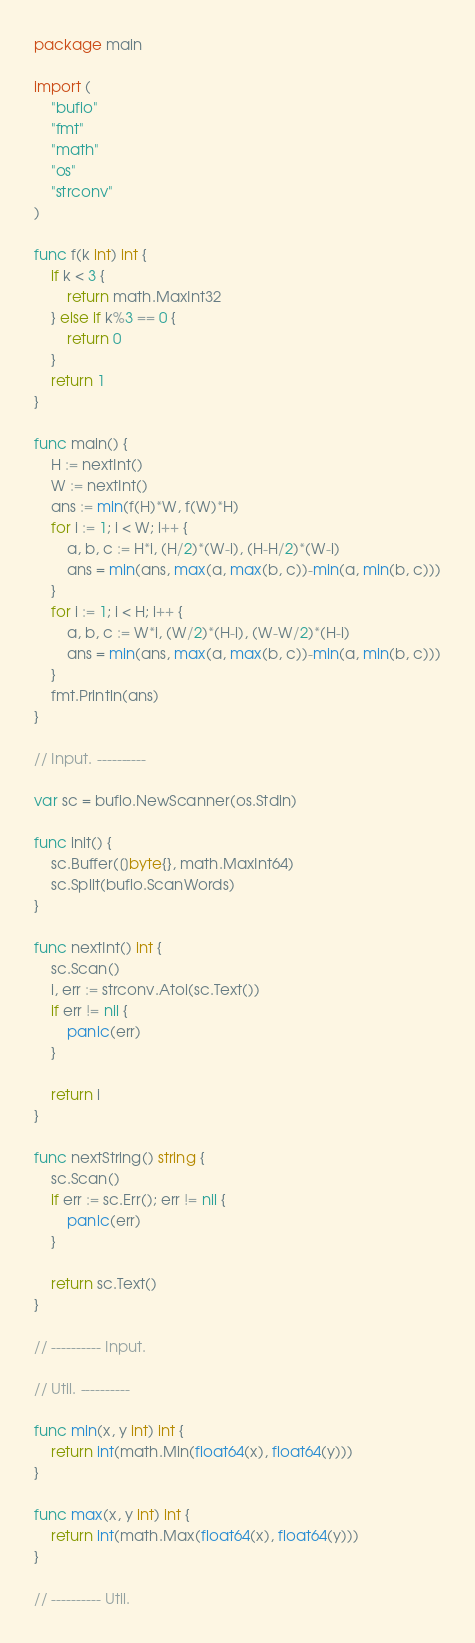Convert code to text. <code><loc_0><loc_0><loc_500><loc_500><_Go_>package main

import (
	"bufio"
	"fmt"
	"math"
	"os"
	"strconv"
)

func f(k int) int {
	if k < 3 {
		return math.MaxInt32
	} else if k%3 == 0 {
		return 0
	}
	return 1
}

func main() {
	H := nextInt()
	W := nextInt()
	ans := min(f(H)*W, f(W)*H)
	for i := 1; i < W; i++ {
		a, b, c := H*i, (H/2)*(W-i), (H-H/2)*(W-i)
		ans = min(ans, max(a, max(b, c))-min(a, min(b, c)))
	}
	for i := 1; i < H; i++ {
		a, b, c := W*i, (W/2)*(H-i), (W-W/2)*(H-i)
		ans = min(ans, max(a, max(b, c))-min(a, min(b, c)))
	}
	fmt.Println(ans)
}

// Input. ----------

var sc = bufio.NewScanner(os.Stdin)

func init() {
	sc.Buffer([]byte{}, math.MaxInt64)
	sc.Split(bufio.ScanWords)
}

func nextInt() int {
	sc.Scan()
	i, err := strconv.Atoi(sc.Text())
	if err != nil {
		panic(err)
	}

	return i
}

func nextString() string {
	sc.Scan()
	if err := sc.Err(); err != nil {
		panic(err)
	}

	return sc.Text()
}

// ---------- Input.

// Util. ----------

func min(x, y int) int {
	return int(math.Min(float64(x), float64(y)))
}

func max(x, y int) int {
	return int(math.Max(float64(x), float64(y)))
}

// ---------- Util.
</code> 